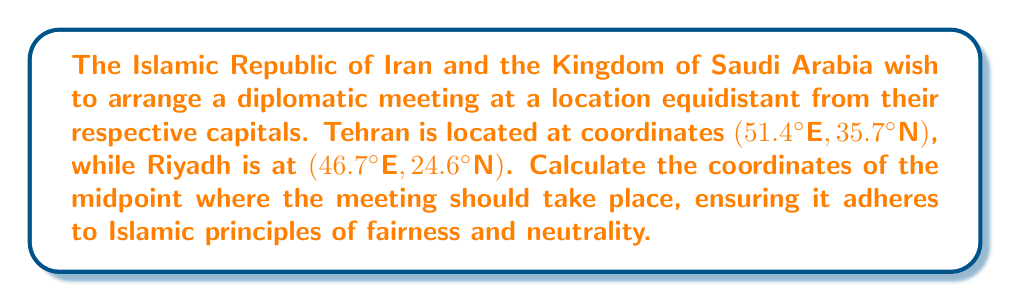Give your solution to this math problem. To find the midpoint between two points in a coordinate system, we use the midpoint formula:

$$ \text{Midpoint} = \left(\frac{x_1 + x_2}{2}, \frac{y_1 + y_2}{2}\right) $$

Where $(x_1, y_1)$ represents the coordinates of the first point (Tehran) and $(x_2, y_2)$ represents the coordinates of the second point (Riyadh).

Let's substitute the given coordinates:

Tehran: $(x_1, y_1) = (51.4°\text{E}, 35.7°\text{N})$
Riyadh: $(x_2, y_2) = (46.7°\text{E}, 24.6°\text{N})$

Now, let's calculate the midpoint:

For the longitude (x-coordinate):
$$ x_{\text{midpoint}} = \frac{x_1 + x_2}{2} = \frac{51.4° + 46.7°}{2} = \frac{98.1°}{2} = 49.05°\text{E} $$

For the latitude (y-coordinate):
$$ y_{\text{midpoint}} = \frac{y_1 + y_2}{2} = \frac{35.7° + 24.6°}{2} = \frac{60.3°}{2} = 30.15°\text{N} $$

Therefore, the coordinates of the midpoint are $(49.05°\text{E}, 30.15°\text{N})$.

This location represents a fair and neutral meeting point between the two capitals, in accordance with Islamic principles of justice and equality.
Answer: The coordinates of the midpoint for the diplomatic meeting are $(49.05°\text{E}, 30.15°\text{N})$. 